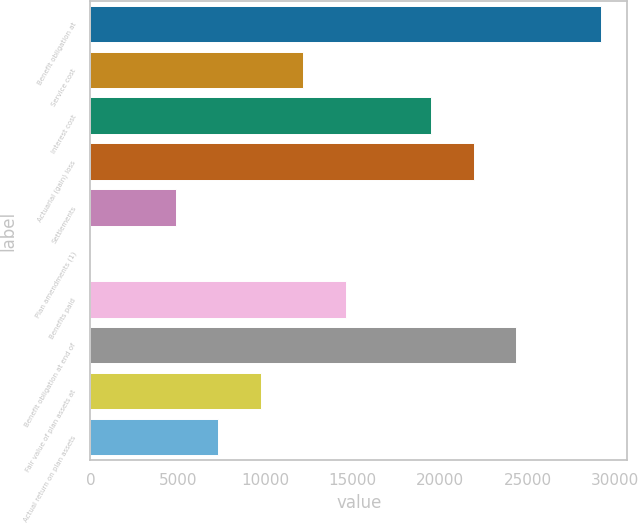Convert chart. <chart><loc_0><loc_0><loc_500><loc_500><bar_chart><fcel>Benefit obligation at<fcel>Service cost<fcel>Interest cost<fcel>Actuarial (gain) loss<fcel>Settlements<fcel>Plan amendments (1)<fcel>Benefits paid<fcel>Benefit obligation at end of<fcel>Fair value of plan assets at<fcel>Actual return on plan assets<nl><fcel>29231.8<fcel>12180.3<fcel>19488.1<fcel>21924<fcel>4872.54<fcel>0.68<fcel>14616.3<fcel>24360<fcel>9744.4<fcel>7308.47<nl></chart> 